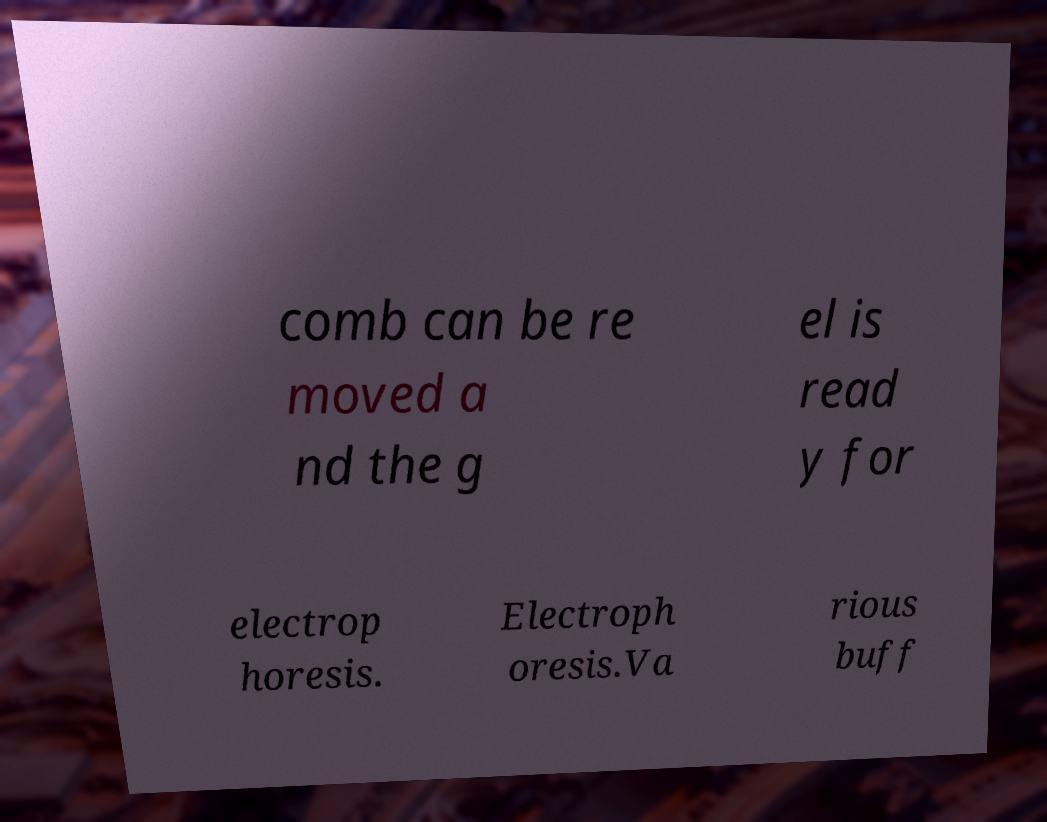Please identify and transcribe the text found in this image. comb can be re moved a nd the g el is read y for electrop horesis. Electroph oresis.Va rious buff 